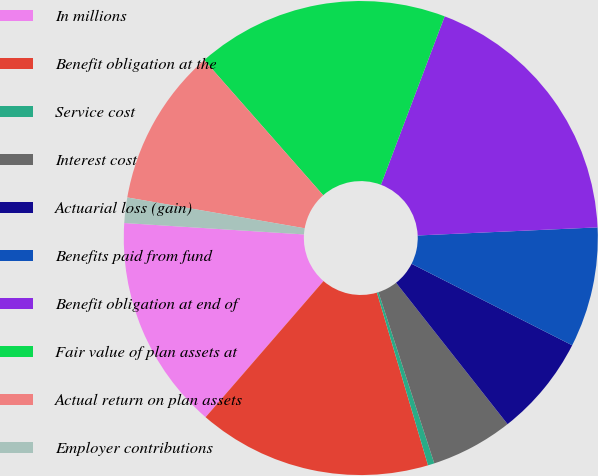Convert chart to OTSL. <chart><loc_0><loc_0><loc_500><loc_500><pie_chart><fcel>In millions<fcel>Benefit obligation at the<fcel>Service cost<fcel>Interest cost<fcel>Actuarial loss (gain)<fcel>Benefits paid from fund<fcel>Benefit obligation at end of<fcel>Fair value of plan assets at<fcel>Actual return on plan assets<fcel>Employer contributions<nl><fcel>14.65%<fcel>15.94%<fcel>0.44%<fcel>5.61%<fcel>6.9%<fcel>8.19%<fcel>18.53%<fcel>17.24%<fcel>10.78%<fcel>1.73%<nl></chart> 